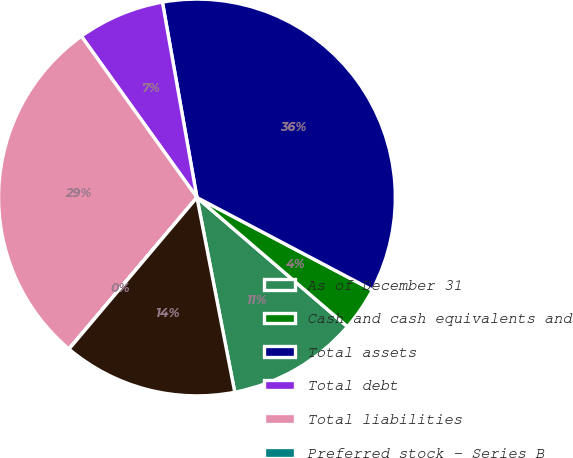Convert chart to OTSL. <chart><loc_0><loc_0><loc_500><loc_500><pie_chart><fcel>As of December 31<fcel>Cash and cash equivalents and<fcel>Total assets<fcel>Total debt<fcel>Total liabilities<fcel>Preferred stock - Series B<fcel>Total stockholders' equity<nl><fcel>10.66%<fcel>3.56%<fcel>35.51%<fcel>7.11%<fcel>28.94%<fcel>0.01%<fcel>14.21%<nl></chart> 